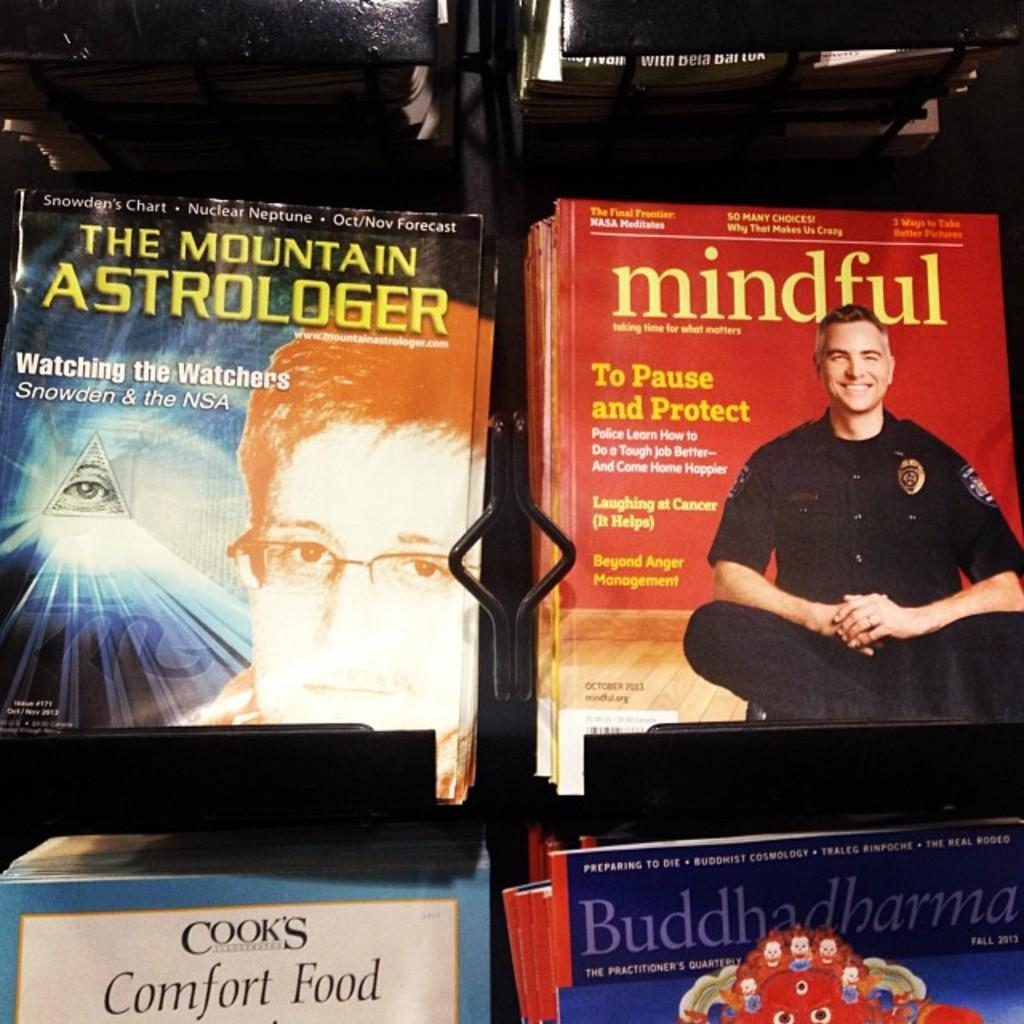<image>
Write a terse but informative summary of the picture. Several magazines are shown together, including "mindful" magazine. 